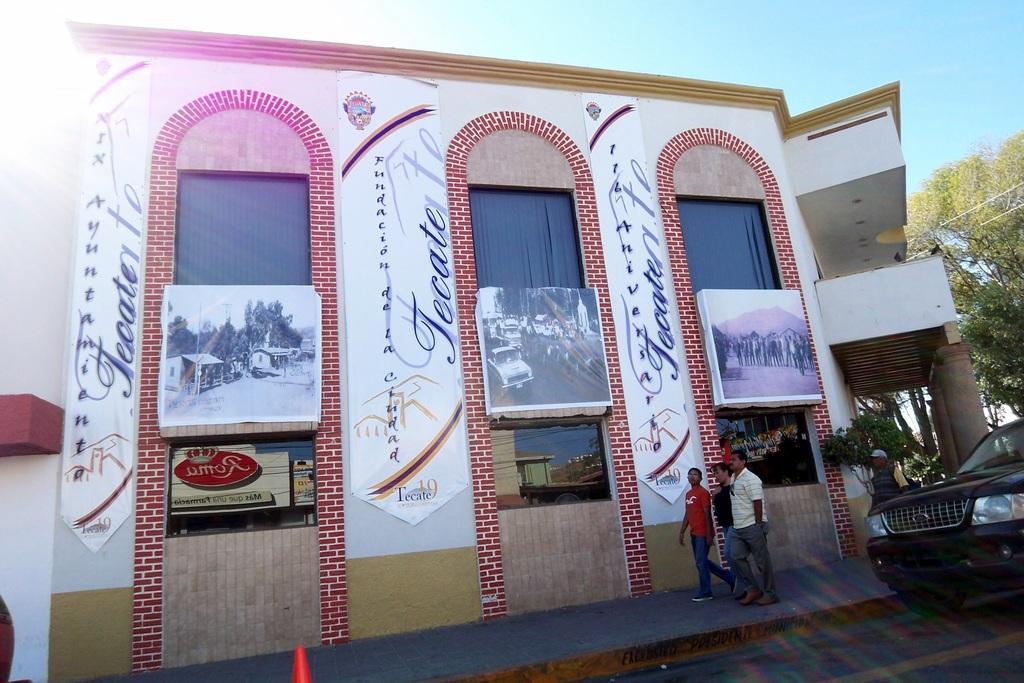How would you summarize this image in a sentence or two? As we can see in the image there are buildings, black color car, few people here and there, trees and sky. 